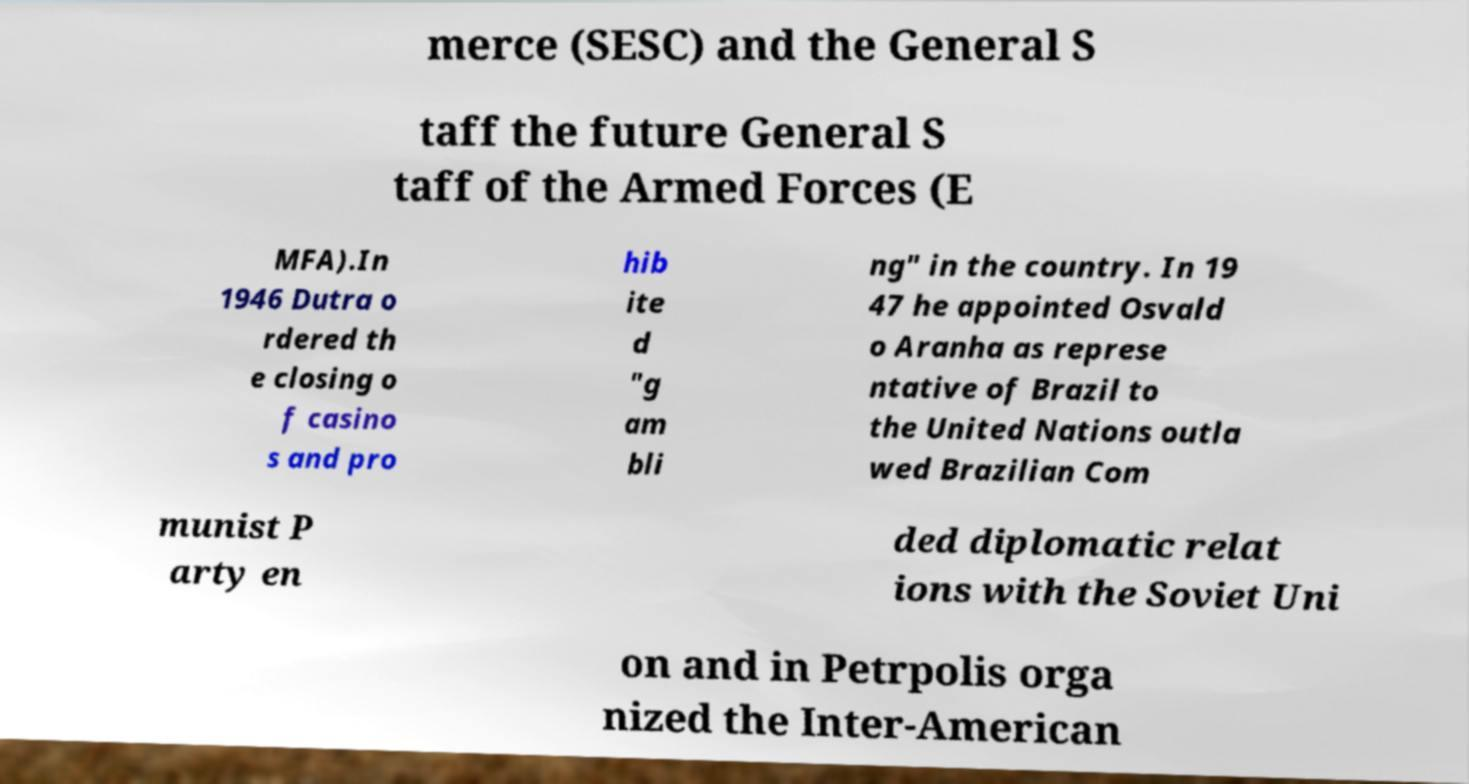Can you accurately transcribe the text from the provided image for me? merce (SESC) and the General S taff the future General S taff of the Armed Forces (E MFA).In 1946 Dutra o rdered th e closing o f casino s and pro hib ite d "g am bli ng" in the country. In 19 47 he appointed Osvald o Aranha as represe ntative of Brazil to the United Nations outla wed Brazilian Com munist P arty en ded diplomatic relat ions with the Soviet Uni on and in Petrpolis orga nized the Inter-American 